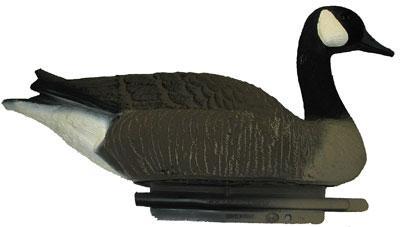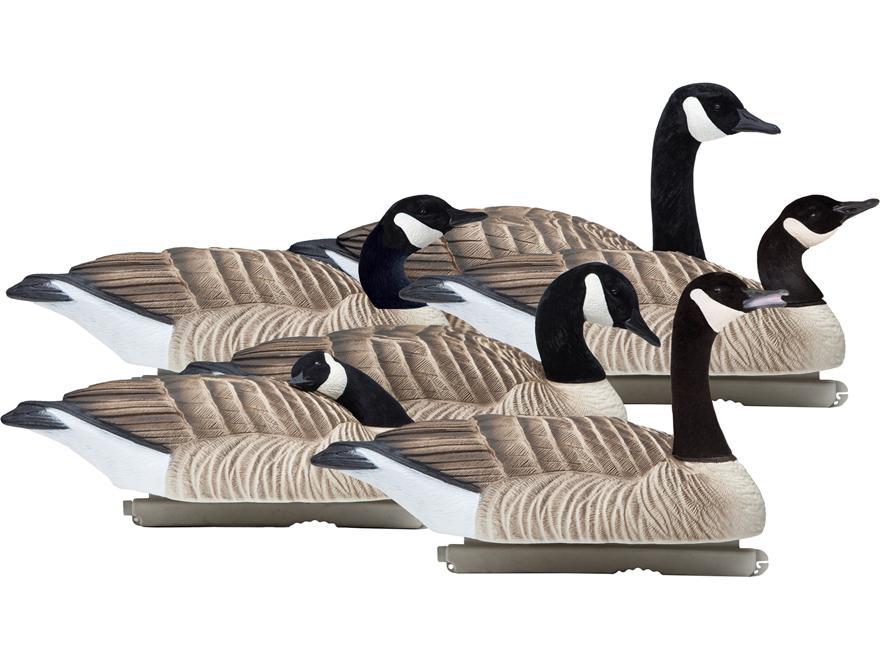The first image is the image on the left, the second image is the image on the right. Assess this claim about the two images: "All decoy birds have black necks, and one image contains at least four decoy birds, while the other image contains just one.". Correct or not? Answer yes or no. Yes. The first image is the image on the left, the second image is the image on the right. Considering the images on both sides, is "There are five duck decoys." valid? Answer yes or no. No. 